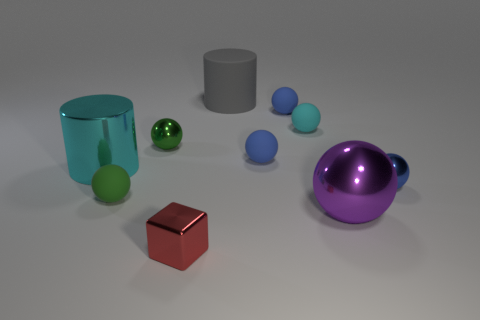What is the shape of the big cyan metallic object? cylinder 